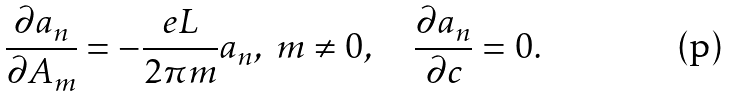Convert formula to latex. <formula><loc_0><loc_0><loc_500><loc_500>\frac { \partial a _ { n } } { \partial A _ { m } } = - \frac { e L } { 2 \pi m } a _ { n } , \ m \neq 0 , \quad \frac { \partial a _ { n } } { \partial c } = 0 .</formula> 